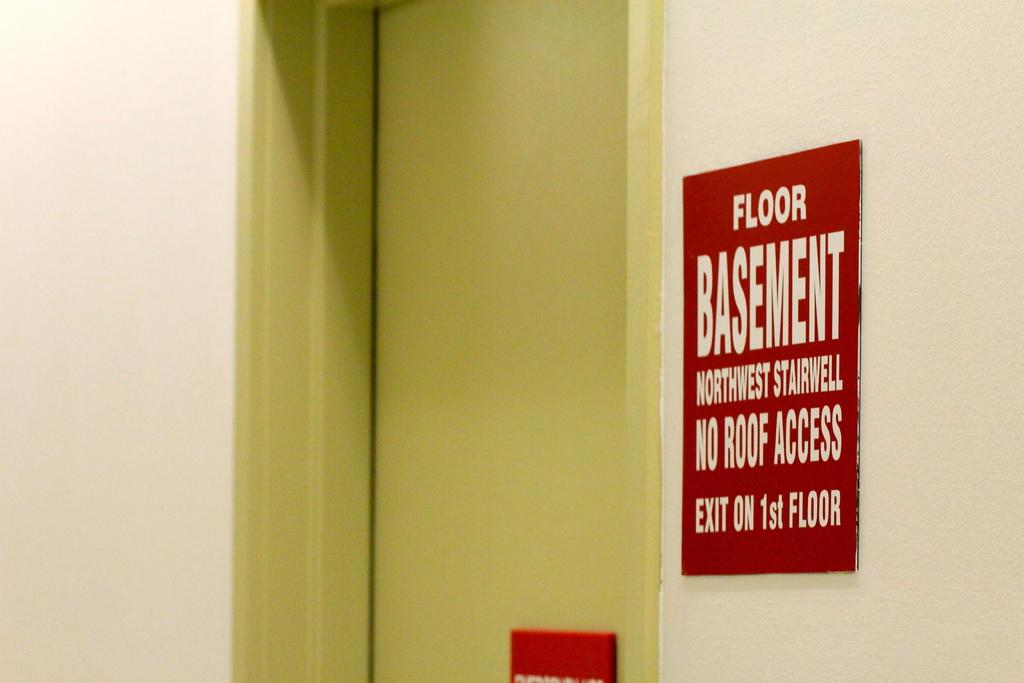<image>
Create a compact narrative representing the image presented. Doorway that leads to stairs and a sign that says Floor Basement Northwest Stairwell No Roof Access Exit on 1st Floor. 